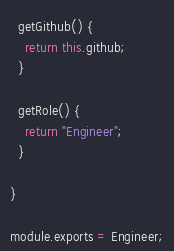<code> <loc_0><loc_0><loc_500><loc_500><_JavaScript_>
  getGithub() {
    return this.github;
  }
  
  getRole() {
    return "Engineer";
  }

}

module.exports = Engineer;
</code> 